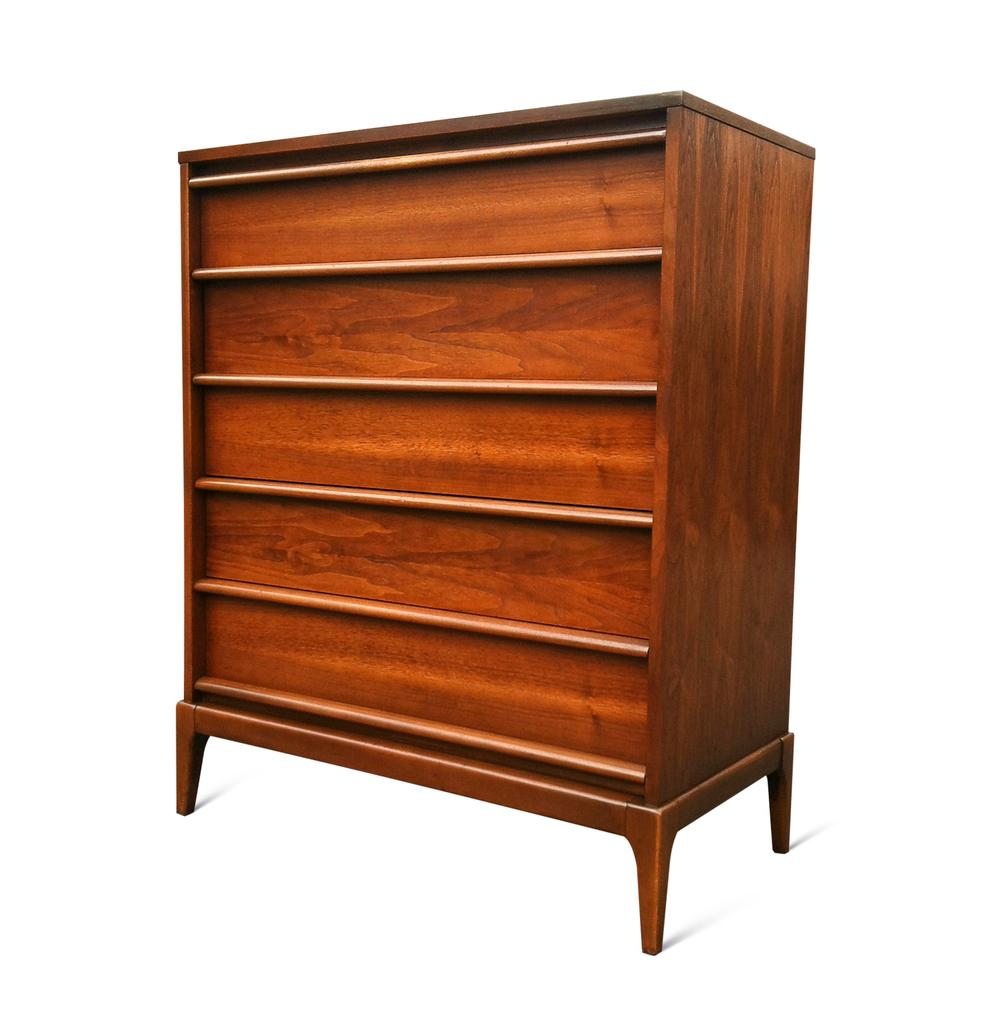What type of furniture is present in the image? There is a wooden cabinet in the image. What color is the background of the image? The background of the image is white. What type of sock is hanging on the wooden cabinet in the image? There is no sock present in the image; it only features a wooden cabinet and a white background. 